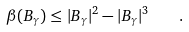Convert formula to latex. <formula><loc_0><loc_0><loc_500><loc_500>\beta ( B _ { \gamma } ) \leq | B _ { \gamma } | ^ { 2 } - | B _ { \gamma } | ^ { 3 } \quad .</formula> 